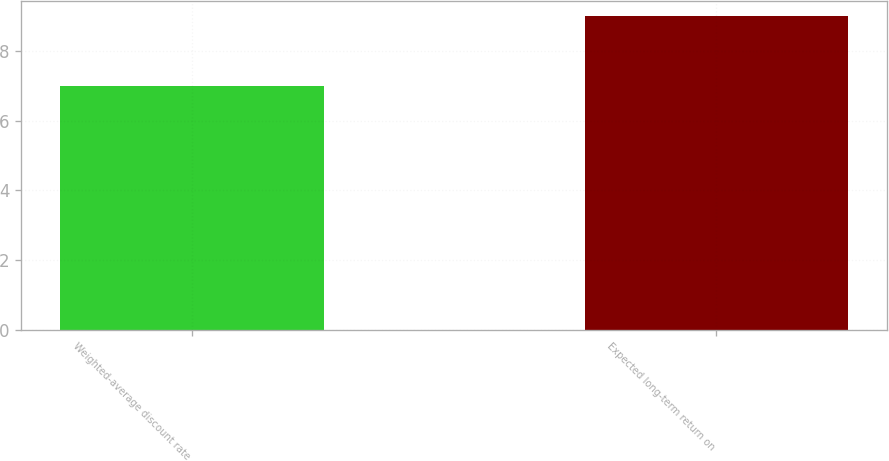Convert chart. <chart><loc_0><loc_0><loc_500><loc_500><bar_chart><fcel>Weighted-average discount rate<fcel>Expected long-term return on<nl><fcel>7<fcel>9<nl></chart> 